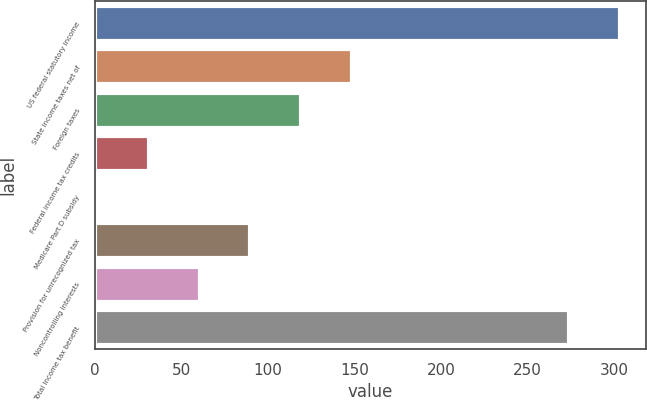Convert chart. <chart><loc_0><loc_0><loc_500><loc_500><bar_chart><fcel>US federal statutory income<fcel>State income taxes net of<fcel>Foreign taxes<fcel>Federal income tax credits<fcel>Medicare Part D subsidy<fcel>Provision for unrecognized tax<fcel>Noncontrolling interests<fcel>Total income tax benefit<nl><fcel>303.3<fcel>148.5<fcel>119.2<fcel>31.3<fcel>2<fcel>89.9<fcel>60.6<fcel>274<nl></chart> 